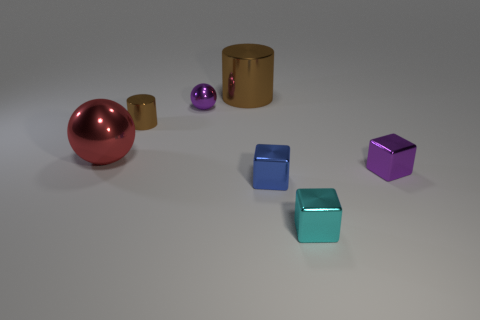Subtract all brown cylinders. How many were subtracted if there are1brown cylinders left? 1 Add 3 big brown metallic cylinders. How many objects exist? 10 Subtract all cylinders. How many objects are left? 5 Subtract all tiny purple blocks. Subtract all big brown cylinders. How many objects are left? 5 Add 4 large brown things. How many large brown things are left? 5 Add 6 tiny cylinders. How many tiny cylinders exist? 7 Subtract 0 red blocks. How many objects are left? 7 